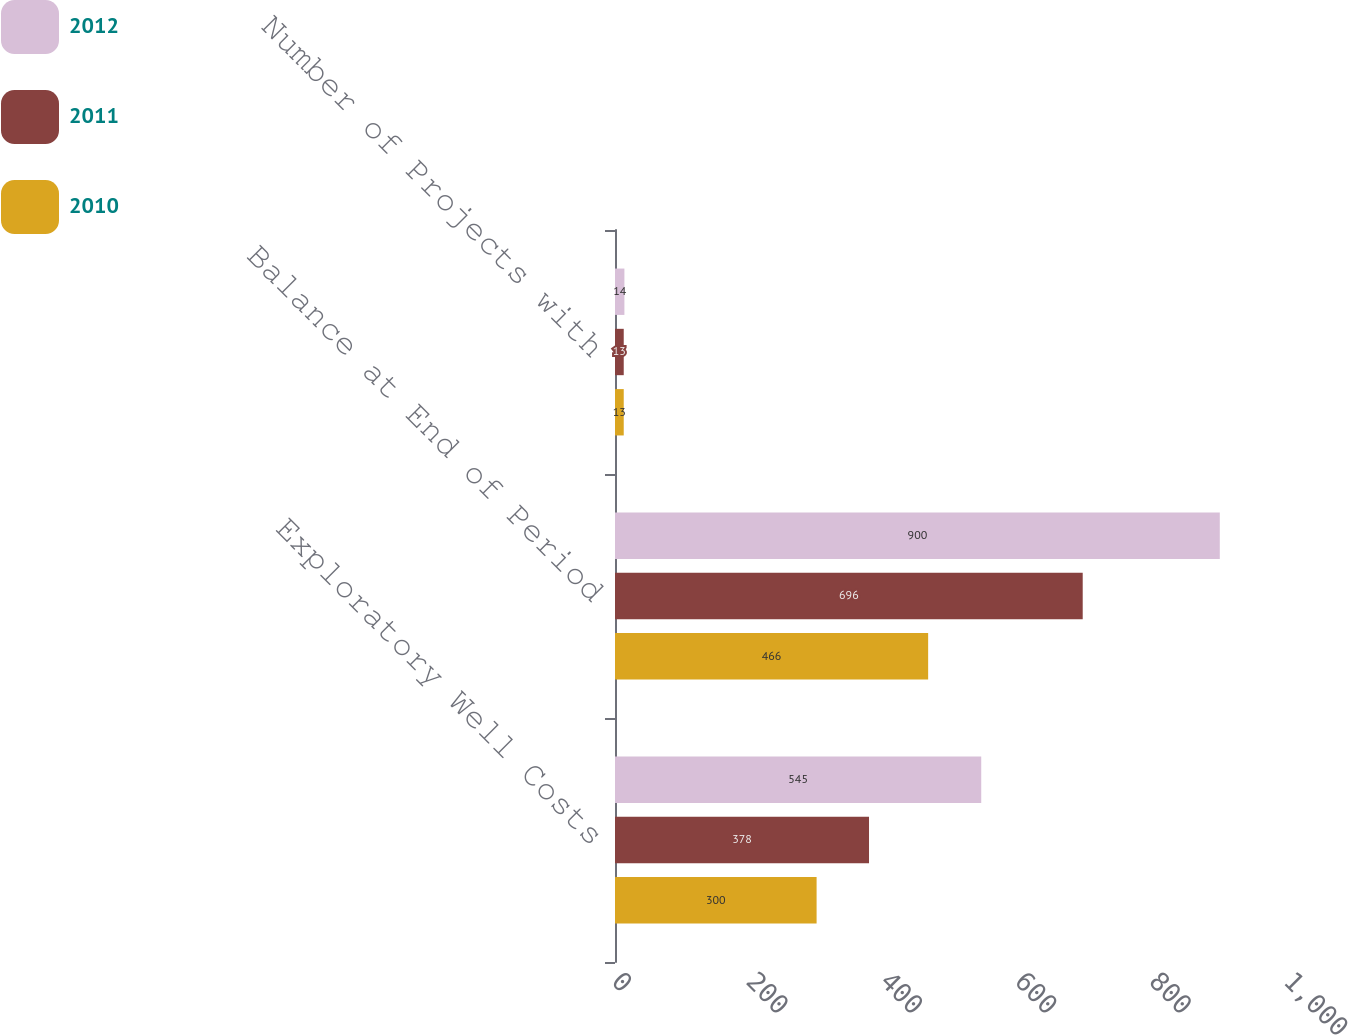Convert chart to OTSL. <chart><loc_0><loc_0><loc_500><loc_500><stacked_bar_chart><ecel><fcel>Exploratory Well Costs<fcel>Balance at End of Period<fcel>Number of Projects with<nl><fcel>2012<fcel>545<fcel>900<fcel>14<nl><fcel>2011<fcel>378<fcel>696<fcel>13<nl><fcel>2010<fcel>300<fcel>466<fcel>13<nl></chart> 